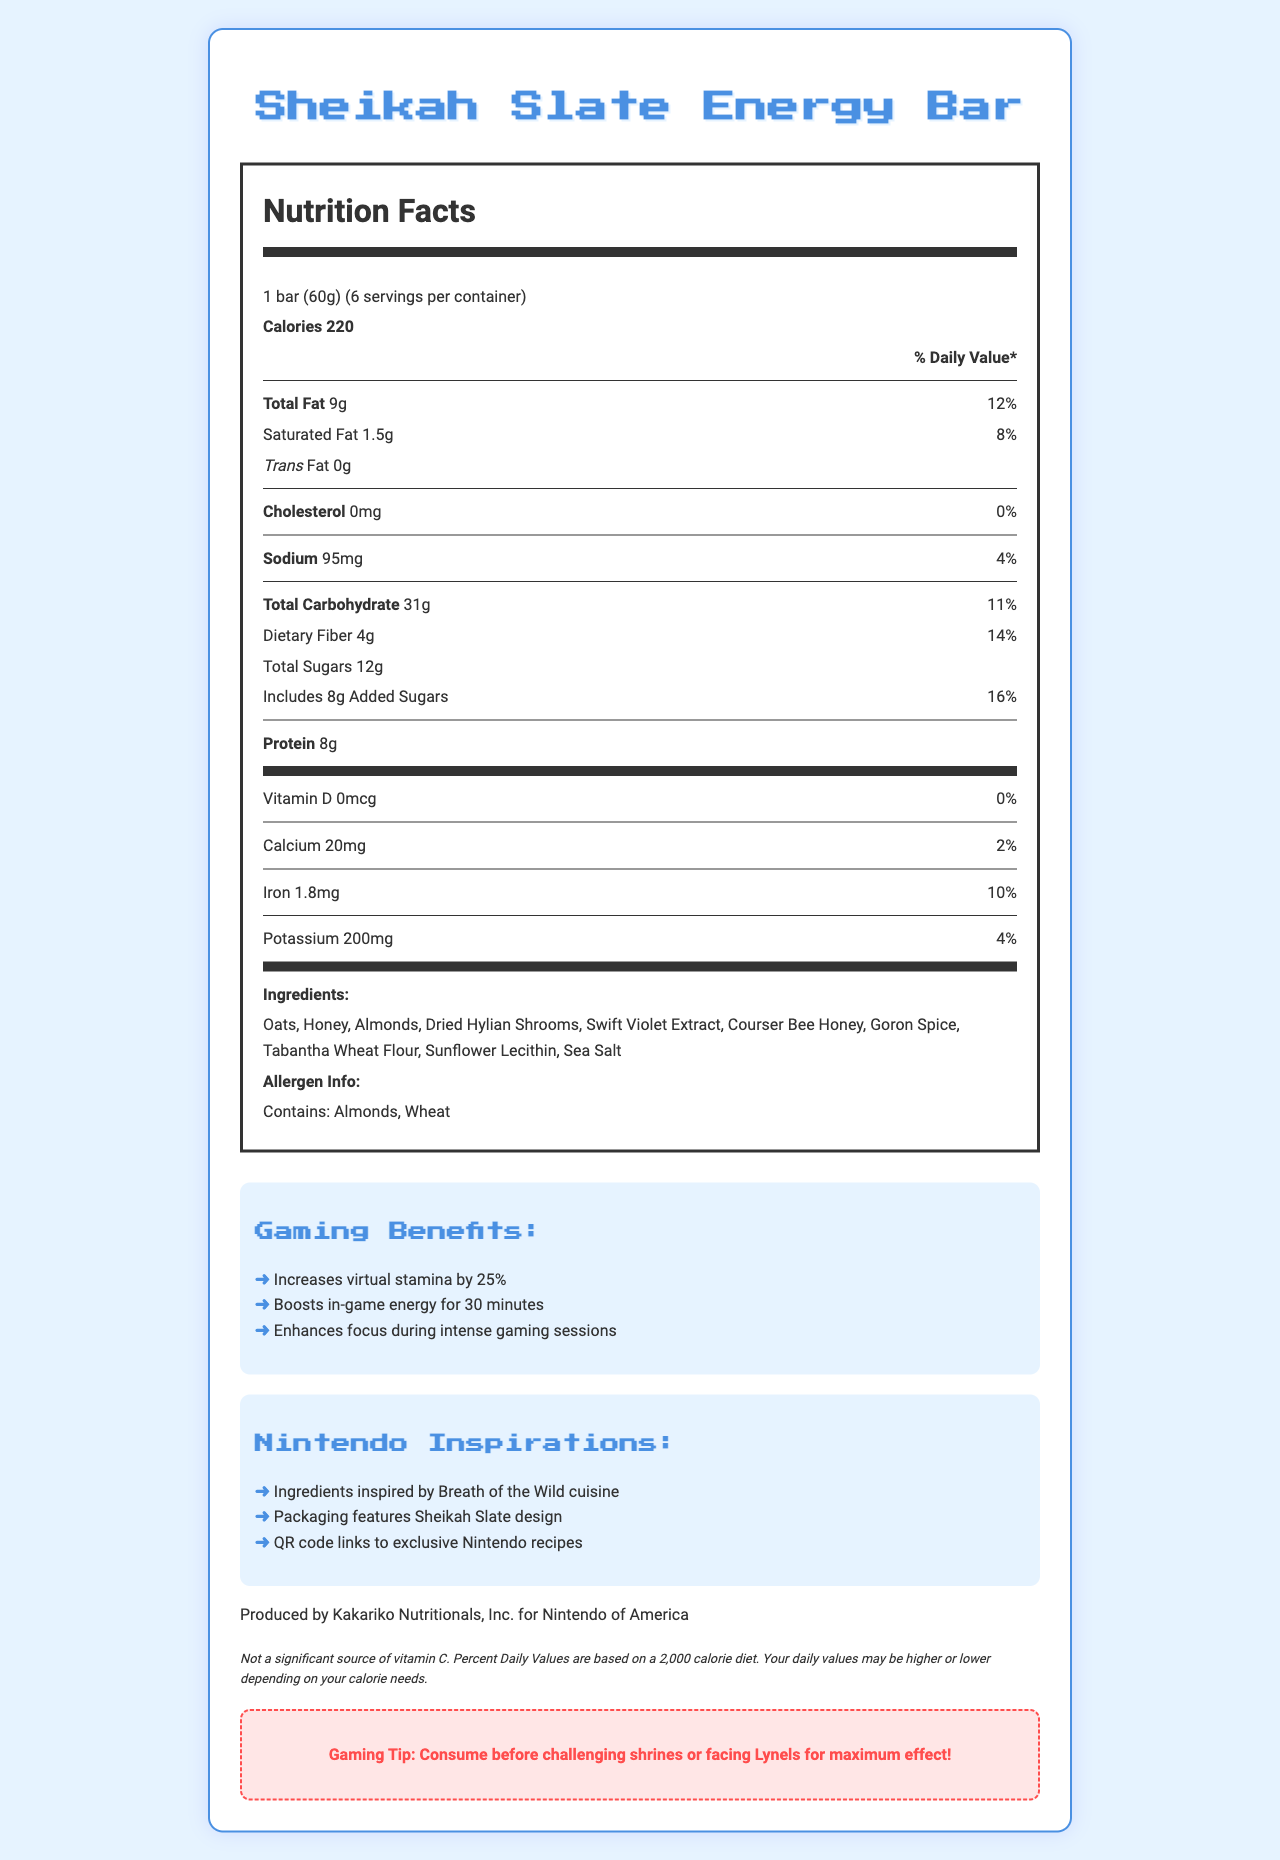what is the serving size of the Sheikah Slate Energy Bar? The serving size is explicitly stated in the Nutrition Facts label as 1 bar (60g).
Answer: 1 bar (60g) how many calories are in one Sheikah Slate Energy Bar? The document mentions that each bar contains 220 calories.
Answer: 220 calories which ingredient is listed first in the Sheikah Slate Energy Bar? The first ingredient listed is Oats, indicating it's the most abundant in the bar.
Answer: Oats how much protein does each bar contain? The document gives the amount of protein in each bar as 8g.
Answer: 8g what percent of the daily value is the dietary fiber content? The dietary fiber percentage of the daily value is listed as 14%.
Answer: 14% what feature is on the packaging of this energy bar? The packaging is described to feature the Sheikah Slate design in the Nintendo Inspirations section.
Answer: Sheikah Slate design how many servings are there per container? A. 4 B. 6 C. 8 D. 12 The document states that there are 6 servings per container.
Answer: B what is the daily value percentage of calcium? A. 0% B. 2% C. 4% D. 10% The percentage of the daily value for calcium is 2%.
Answer: B is the Sheikah Slate Energy Bar a significant source of vitamin D? Yes/No The document explicitly mentions that the bars are not a significant source of vitamin D, with 0% daily value.
Answer: No describe the main idea of the document. The document primarily focuses on nutrition facts along with gaming benefits, allergen information, and Nintendo-themed inspirations to provide comprehensive details about the product.
Answer: The main idea of the document is to provide detailed nutritional information about the Sheikah Slate Energy Bar. It includes serving size, calorie content, breakdown of fats, carbohydrates, protein amounts, vitamins, and minerals content, as well as ingredients, allergen information, gaming benefits, and inspirations from The Legend of Zelda: Breath of the Wild. what is the function of Swift Violet Extract in the bar? The document lists Swift Violet Extract as an ingredient, but it does not provide specific information about its function.
Answer: Not enough information how many calories come from fat per serving? The document provides total calories and fat content but does not specify how many of the calories come from fat.
Answer: Not specified 